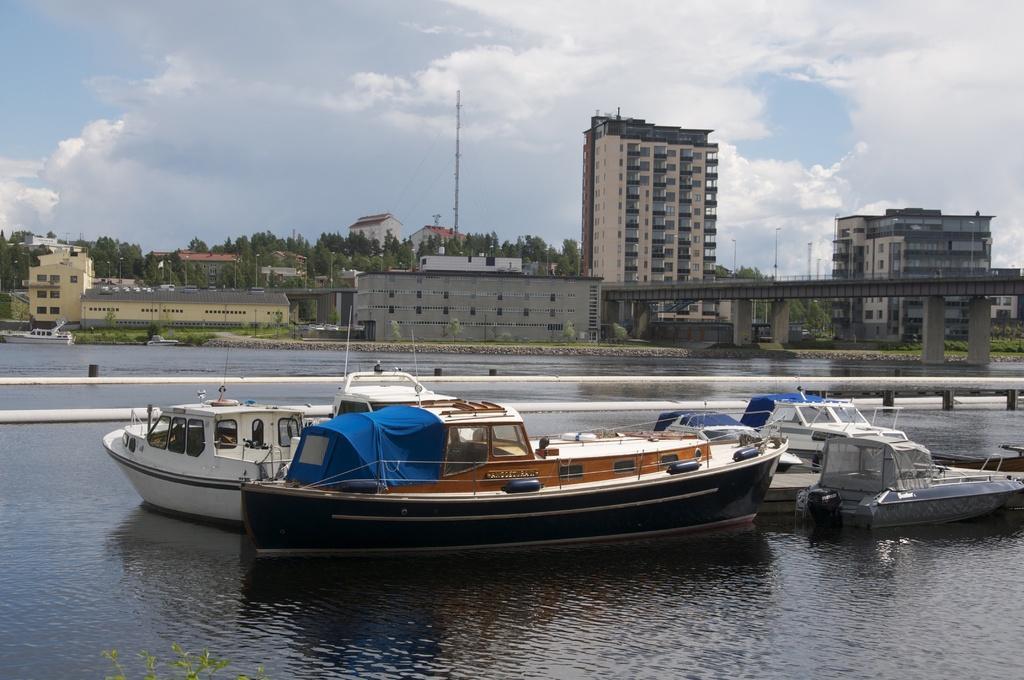In one or two sentences, can you explain what this image depicts? At the bottom of the image on the water there are ships. And there is a bridge with pillars. In the background there are many buildings and trees. At the top of the image there is sky with clouds. 